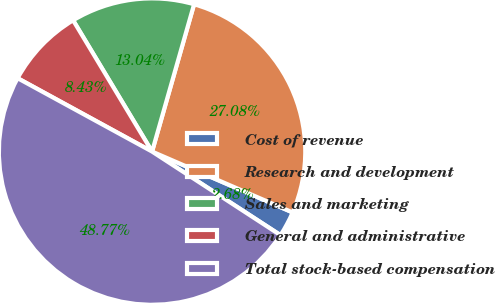Convert chart. <chart><loc_0><loc_0><loc_500><loc_500><pie_chart><fcel>Cost of revenue<fcel>Research and development<fcel>Sales and marketing<fcel>General and administrative<fcel>Total stock-based compensation<nl><fcel>2.68%<fcel>27.08%<fcel>13.04%<fcel>8.43%<fcel>48.77%<nl></chart> 